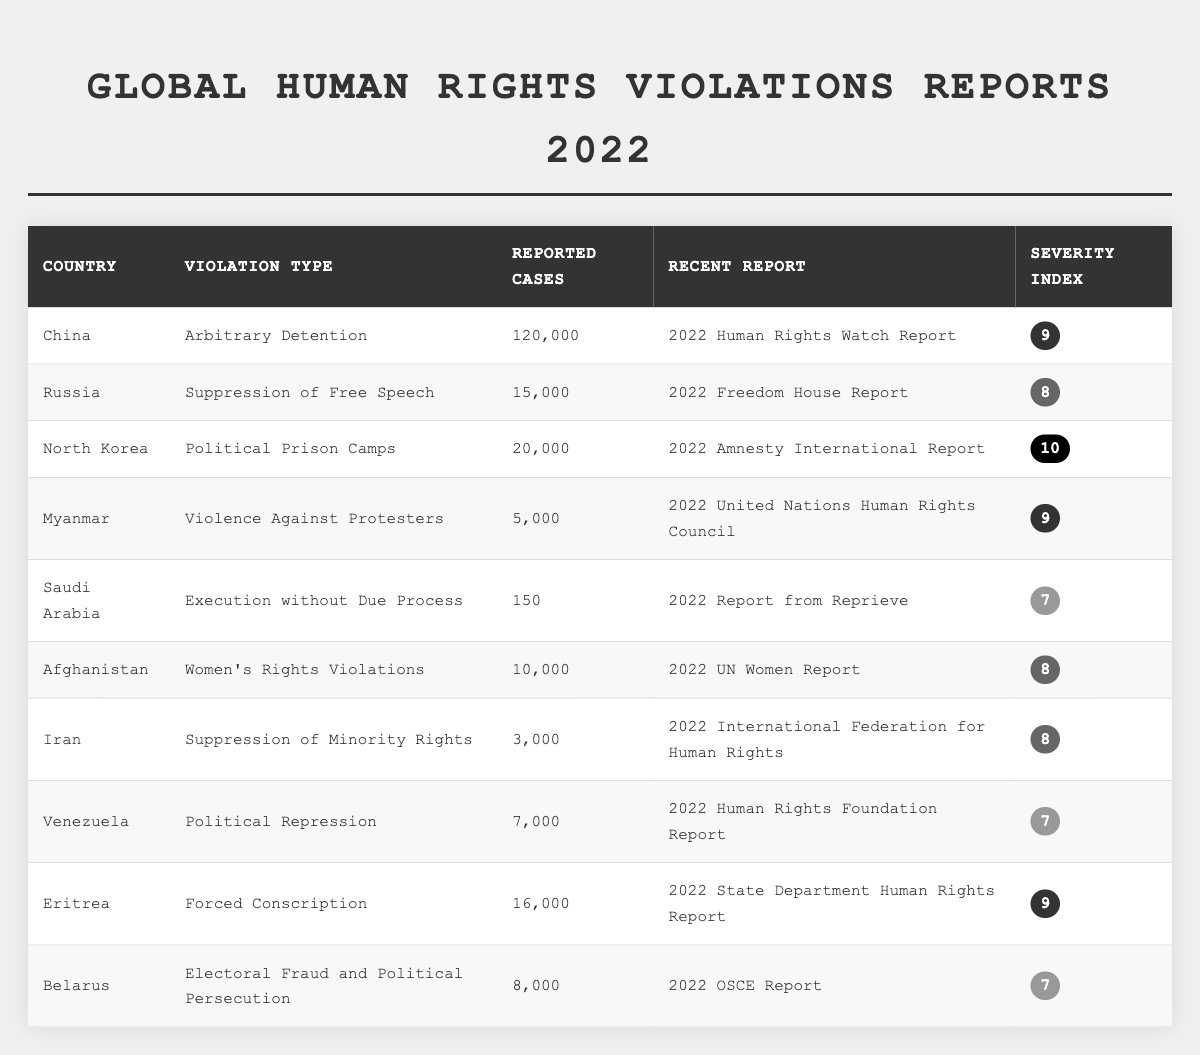What is the country with the highest number of reported cases? From the table, China has the highest reported cases with 120,000 for arbitrary detention.
Answer: China Which violation type has the lowest reported cases? The table shows that "Execution without Due Process" in Saudi Arabia has the lowest reported cases, with only 150.
Answer: Execution without Due Process What is the severity index of North Korea? According to the table, North Korea has a severity index of 10 for the violation type "Political Prison Camps."
Answer: 10 How many countries reported violations with a severity index of 9? The table indicates that there are three countries (China, Myanmar, and Eritrea) with a severity index of 9.
Answer: 3 Is there any country that reported fewer than 5,000 cases? Yes, Saudi Arabia reported 150 cases, which is fewer than 5,000.
Answer: Yes What is the total number of reported cases for all countries listed? By adding the reported cases: 120000 + 15000 + 20000 + 5000 + 150 + 10000 + 3000 + 7000 + 16000 + 8000 = 186155.
Answer: 186155 Which violation type has a severity index of 8? The table shows that "Suppression of Free Speech," "Women's Rights Violations," and "Suppression of Minority Rights" all have a severity index of 8.
Answer: Three types Which country has the most severe human rights violations according to the severity index? North Korea, with a severity index of 10 for "Political Prison Camps," has the most severe violations.
Answer: North Korea What is the average number of reported cases for countries with a severity index of 7? The countries with an index of 7 are Saudi Arabia (150), Venezuela (7000), and Belarus (8000). The total is 150 + 7000 + 8000 = 8150, and the average is 8150/3 = 2716.67.
Answer: 2716.67 Which country has the highest severity index among those reporting cases of violence? Myanmar reports "Violence Against Protesters" with a severity index of 9, which is the highest among reporting countries with this type.
Answer: Myanmar 